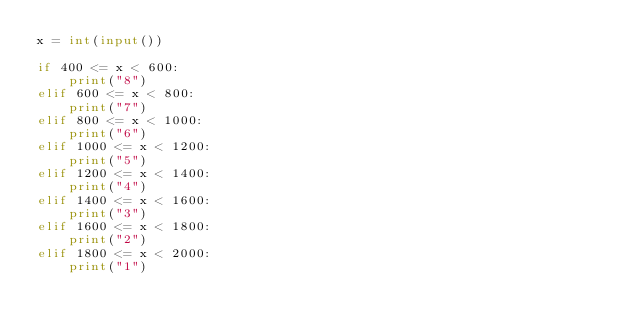Convert code to text. <code><loc_0><loc_0><loc_500><loc_500><_Python_>x = int(input())

if 400 <= x < 600:
    print("8")
elif 600 <= x < 800:
    print("7")
elif 800 <= x < 1000:
    print("6")
elif 1000 <= x < 1200:
    print("5")
elif 1200 <= x < 1400:
    print("4")
elif 1400 <= x < 1600:
    print("3")
elif 1600 <= x < 1800:
    print("2")
elif 1800 <= x < 2000:
    print("1")
</code> 